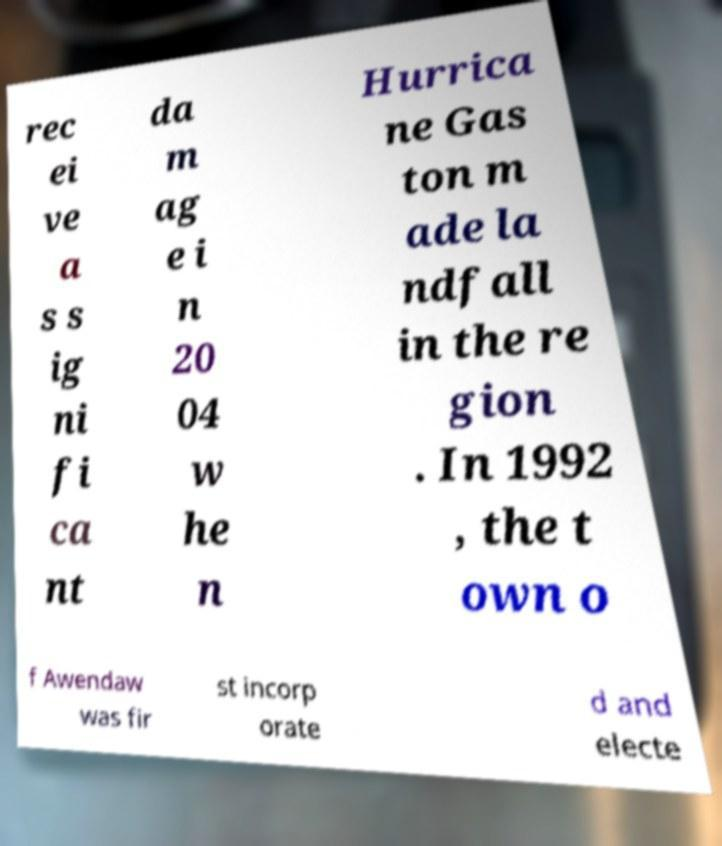Please read and relay the text visible in this image. What does it say? rec ei ve a s s ig ni fi ca nt da m ag e i n 20 04 w he n Hurrica ne Gas ton m ade la ndfall in the re gion . In 1992 , the t own o f Awendaw was fir st incorp orate d and electe 